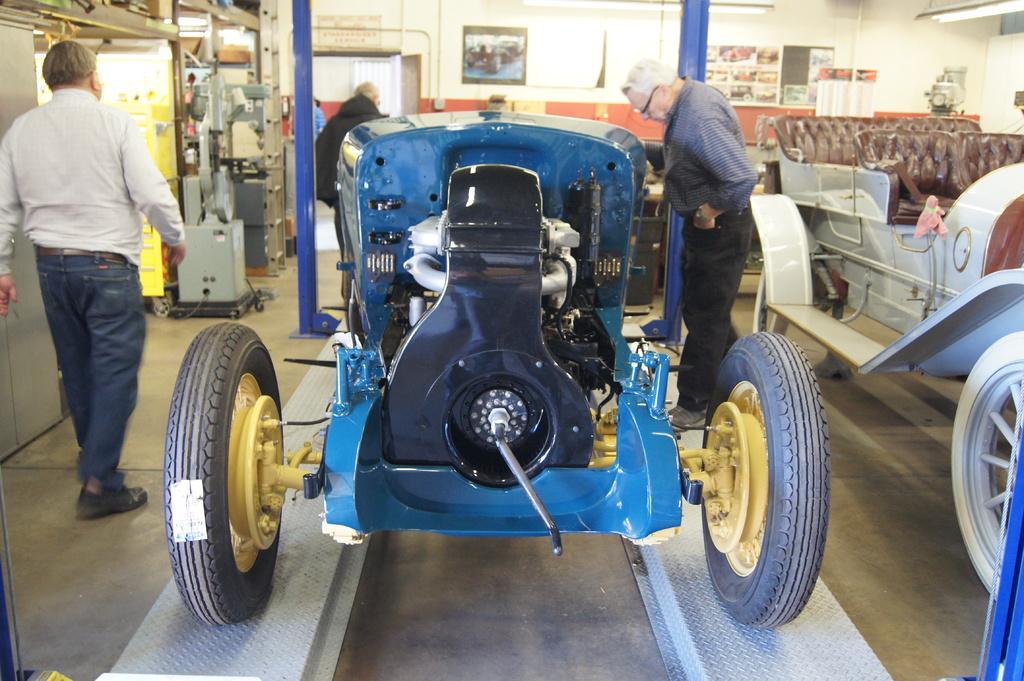Could you give a brief overview of what you see in this image? In this image, in the middle, we can see a vehicle which is placed on the floor. On the right side, we can see a man standing in front of the vehicle. On the right side, we can also see another vehicle. On the left side, we can see a man walking. In the background, we can see some metal instrument, pole, photo frame which is attached to a wall and a door is opened. 